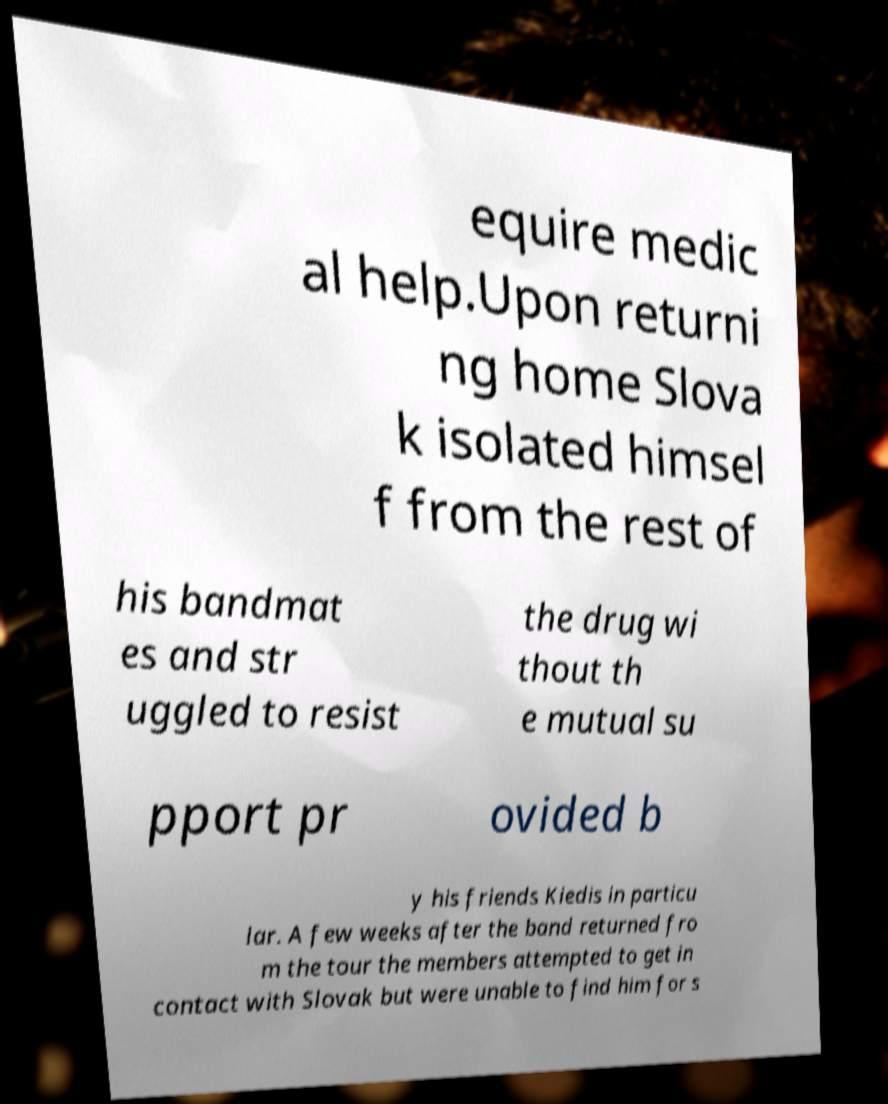Please read and relay the text visible in this image. What does it say? equire medic al help.Upon returni ng home Slova k isolated himsel f from the rest of his bandmat es and str uggled to resist the drug wi thout th e mutual su pport pr ovided b y his friends Kiedis in particu lar. A few weeks after the band returned fro m the tour the members attempted to get in contact with Slovak but were unable to find him for s 